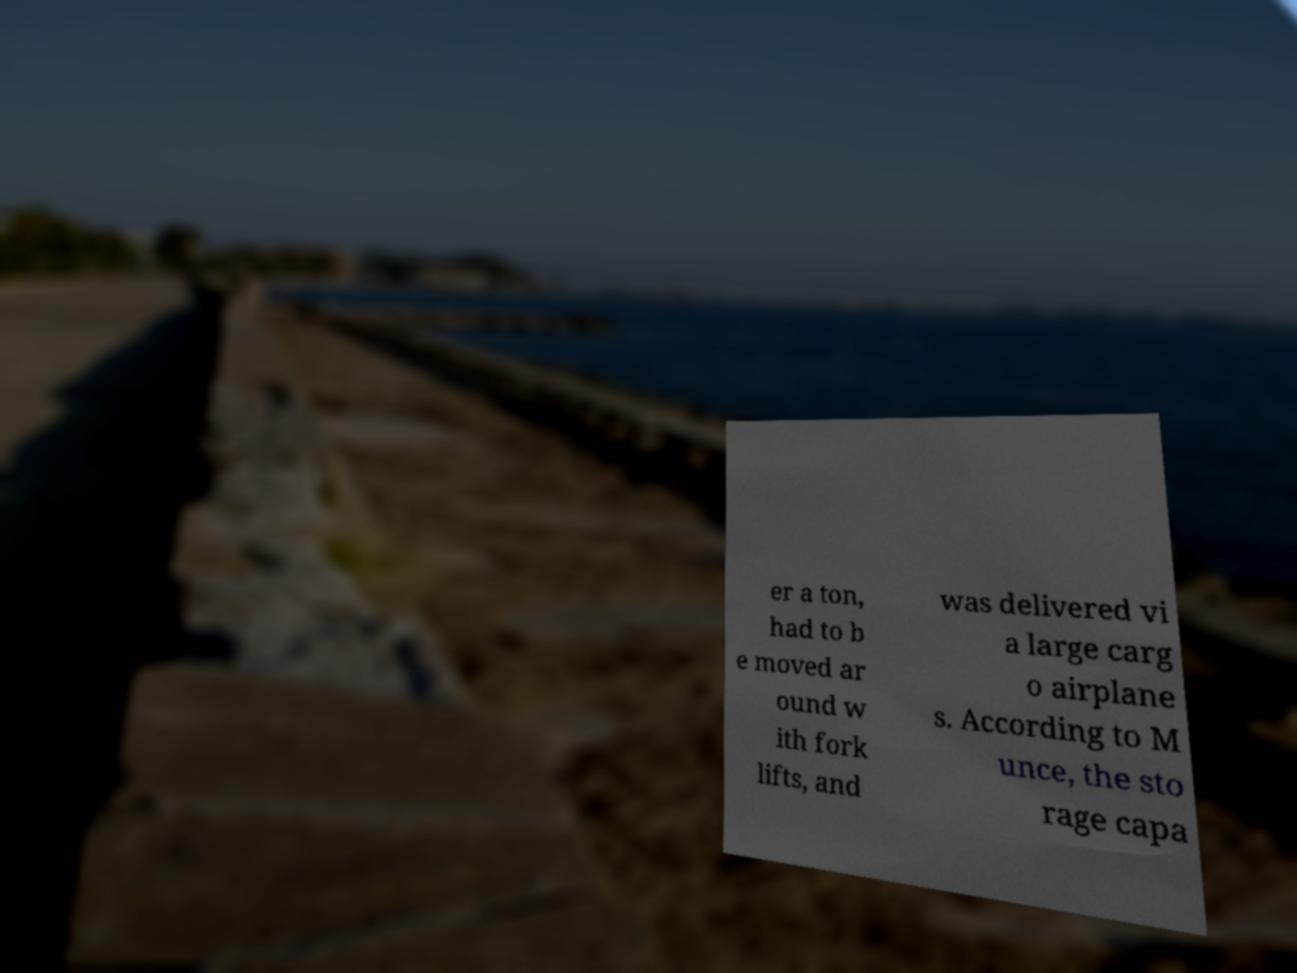What messages or text are displayed in this image? I need them in a readable, typed format. er a ton, had to b e moved ar ound w ith fork lifts, and was delivered vi a large carg o airplane s. According to M unce, the sto rage capa 